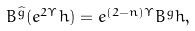Convert formula to latex. <formula><loc_0><loc_0><loc_500><loc_500>B ^ { \widehat { g } } ( e ^ { 2 \Upsilon } h ) = e ^ { ( 2 - n ) \Upsilon } B ^ { g } h ,</formula> 